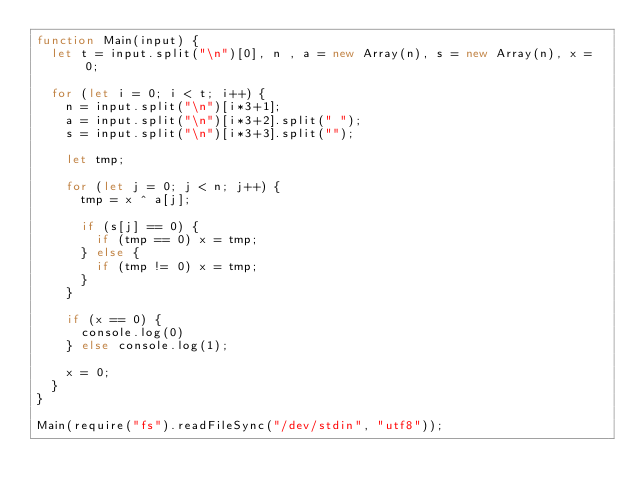<code> <loc_0><loc_0><loc_500><loc_500><_JavaScript_>function Main(input) {
  let t = input.split("\n")[0], n , a = new Array(n), s = new Array(n), x = 0;
  
  for (let i = 0; i < t; i++) {
    n = input.split("\n")[i*3+1];
    a = input.split("\n")[i*3+2].split(" ");
    s = input.split("\n")[i*3+3].split("");

    let tmp;

    for (let j = 0; j < n; j++) {
      tmp = x ^ a[j];
      
      if (s[j] == 0) {
        if (tmp == 0) x = tmp;
      } else {
        if (tmp != 0) x = tmp;
      }
    }
    
    if (x == 0) {
      console.log(0)
    } else console.log(1);
    
    x = 0;
  }
}

Main(require("fs").readFileSync("/dev/stdin", "utf8"));</code> 